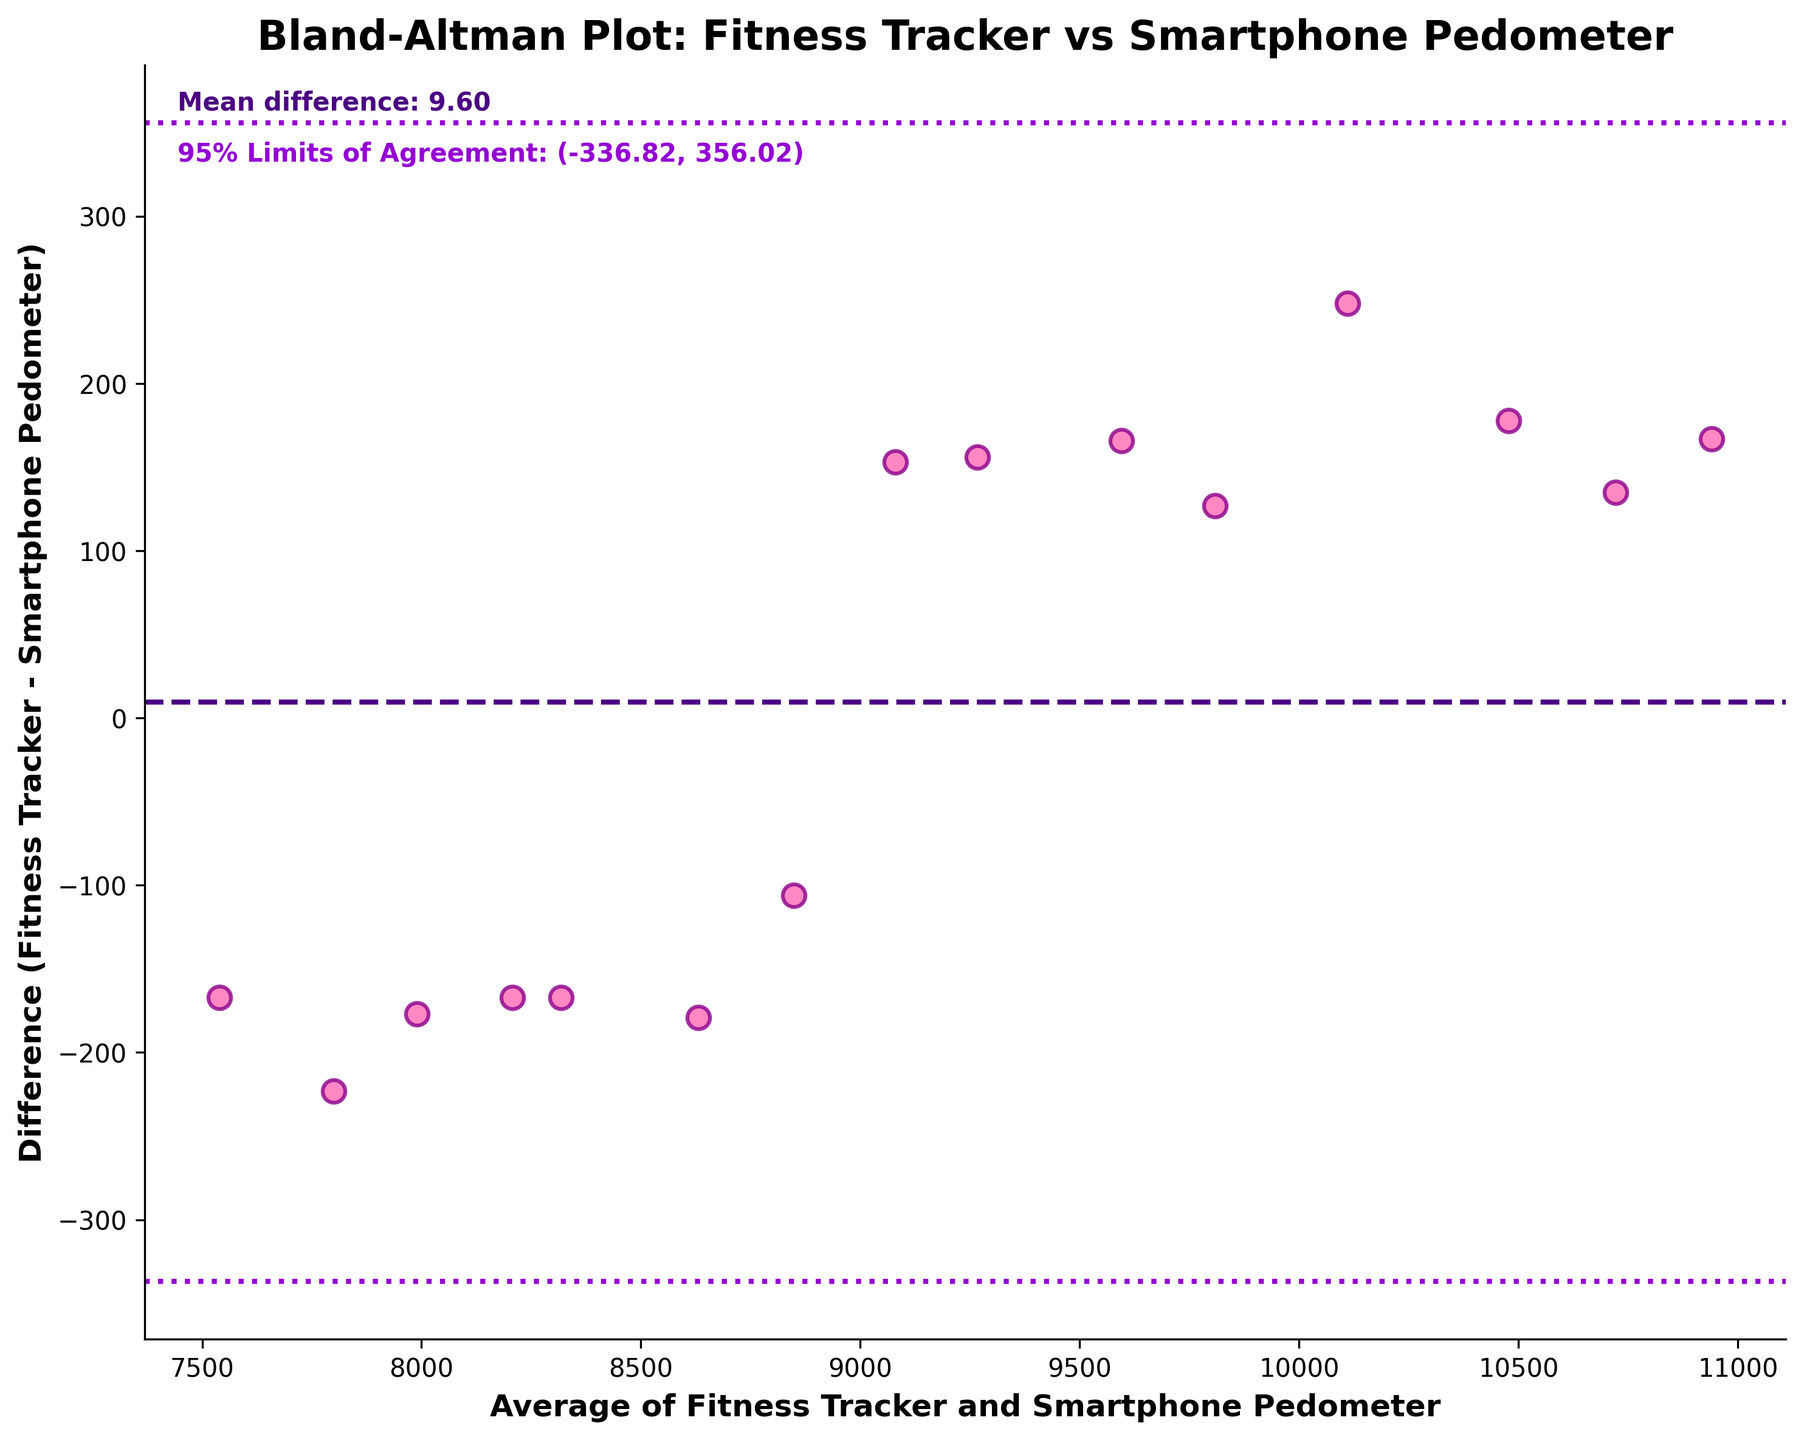What does the title of the plot indicate? The title of the plot is "Bland-Altman Plot: Fitness Tracker vs Smartphone Pedometer," which indicates that this plot is used to compare daily step counts recorded by fitness trackers and smartphone pedometers.
Answer: It indicates a comparison between fitness trackers and smartphone pedometers for daily step counts How many data points are there in the plot? To determine the number of data points, count the number of scatter points shown on the plot.
Answer: 15 What does the x-axis represent? The x-axis label reads "Average of Fitness Tracker and Smartphone Pedometer." Therefore, the x-axis represents the average number of steps recorded by both devices.
Answer: Average step counts of both devices What does the y-axis represent? The y-axis label reads "Difference (Fitness Tracker - Smartphone Pedometer)." Therefore, the y-axis represents the difference in step counts between the fitness tracker and the smartphone pedometer.
Answer: Difference in step counts (Fitness Tracker - Smartphone Pedometer) What is the mean difference between the fitness tracker and the smartphone pedometer? The figure includes a text label indicating the mean difference. It states "Mean difference: X," where X is the value.
Answer: The mean difference between the two devices What are the 95% limits of agreement for this comparison? The figure includes a text label indicating "95% Limits of Agreement: (Y, Z)," where Y and Z are the values representing the lower and upper limits, respectively.
Answer: (lower limit, upper limit) What can you say about the agreement between the two devices based on the 95% limits of agreement? By examining the spread of data points within the 95% limits of agreement, we can conclude how well the two devices agree. Most points should lie within the limits if there is good agreement.
Answer: Data points agree well if most lie within the 95% limits How many data points are outside the 95% limits of agreement? To find this, count the number of data points that fall outside the two dashed lines representing the 95% limits of agreement.
Answer: Number of points outside the limits Which device tends to record higher step counts on average based on this plot? By examining the direction of the mean difference and the positioning of the data points, we can determine which device tends to record higher step counts. If the mean difference is positive, the fitness tracker records higher counts on average, and if negative, the smartphone pedometer records higher counts.
Answer: Device with higher recorded step counts Is there any trend or pattern noticeable in the scatter points? Assess if the scatter points show any specific trends or patterns, such as clustering or a slope, which might indicate a systematic difference between the two devices under certain conditions.
Answer: Any noticed trend or pattern 